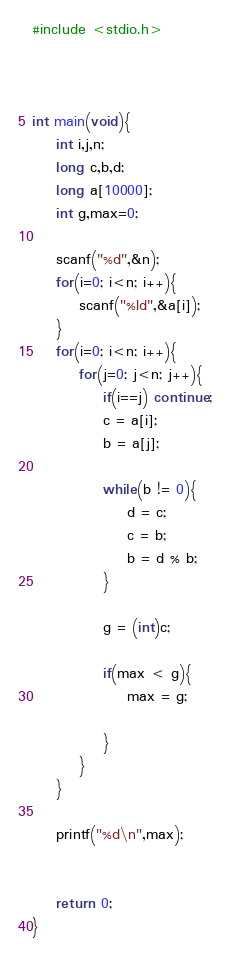Convert code to text. <code><loc_0><loc_0><loc_500><loc_500><_C_>#include <stdio.h>



int main(void){
    int i,j,n;
    long c,b,d;
    long a[10000];
    int g,max=0;

    scanf("%d",&n);
    for(i=0; i<n; i++){
        scanf("%ld",&a[i]);
    }
    for(i=0; i<n; i++){
        for(j=0; j<n; j++){
            if(i==j) continue;
            c = a[i];
            b = a[j];
            
            while(b != 0){
                d = c;
                c = b;
                b = d % b;
            }
            
            g = (int)c;
            
            if(max < g){
                max = g;
                
            }
        }
    }
    
    printf("%d\n",max);
    

    return 0;
}</code> 